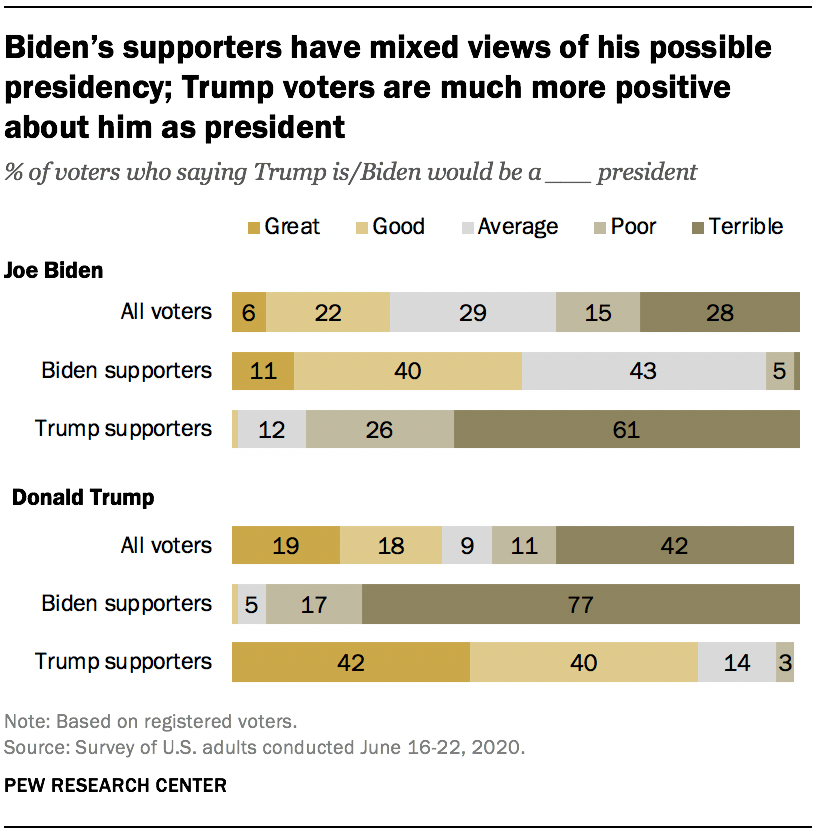Point out several critical features in this image. According to a survey, 46% of people believe that Donald Trump would be a good president. According to a survey of all voters, 28% believe that Joe Biden would make a terrible president. 